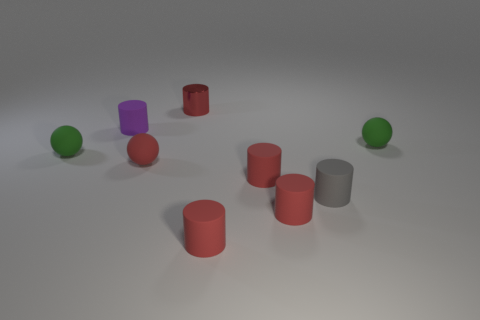Is there anything else that has the same material as the gray cylinder?
Keep it short and to the point. Yes. What is the tiny purple thing made of?
Your answer should be compact. Rubber. Does the red sphere have the same material as the tiny purple cylinder?
Make the answer very short. Yes. How many matte things are either gray objects or tiny green spheres?
Provide a succinct answer. 3. There is a tiny green matte thing that is left of the small red metallic cylinder; what is its shape?
Your response must be concise. Sphere. There is a gray thing that is the same material as the purple cylinder; what size is it?
Your response must be concise. Small. What is the shape of the small red object that is behind the gray object and right of the red metallic cylinder?
Provide a succinct answer. Cylinder. There is a matte sphere left of the small purple matte cylinder; is its color the same as the shiny object?
Keep it short and to the point. No. Do the tiny red rubber thing to the left of the red metal thing and the small object that is on the right side of the gray cylinder have the same shape?
Offer a very short reply. Yes. What is the size of the ball on the right side of the tiny red shiny cylinder?
Make the answer very short. Small. 